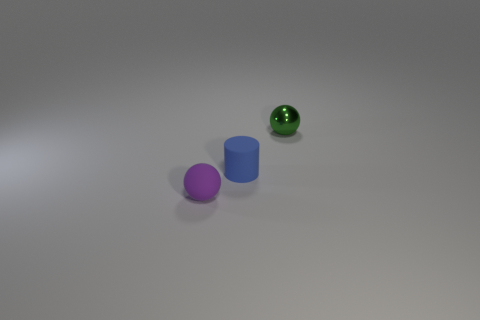What number of cyan cylinders are there?
Keep it short and to the point. 0. Are there the same number of tiny purple matte objects that are in front of the rubber ball and tiny cylinders that are in front of the metal ball?
Offer a very short reply. No. Are there any small cylinders behind the rubber cylinder?
Make the answer very short. No. There is a sphere that is in front of the green object; what is its color?
Ensure brevity in your answer.  Purple. The sphere on the right side of the small sphere left of the metal sphere is made of what material?
Make the answer very short. Metal. Are there fewer tiny green metal balls that are on the right side of the blue rubber cylinder than shiny balls right of the small metal object?
Make the answer very short. No. How many yellow objects are metal spheres or tiny balls?
Give a very brief answer. 0. Are there an equal number of tiny purple rubber balls that are behind the purple rubber thing and small purple rubber balls?
Make the answer very short. No. How many things are green objects or small spheres that are in front of the tiny green sphere?
Make the answer very short. 2. Is the color of the tiny matte sphere the same as the small rubber cylinder?
Ensure brevity in your answer.  No. 